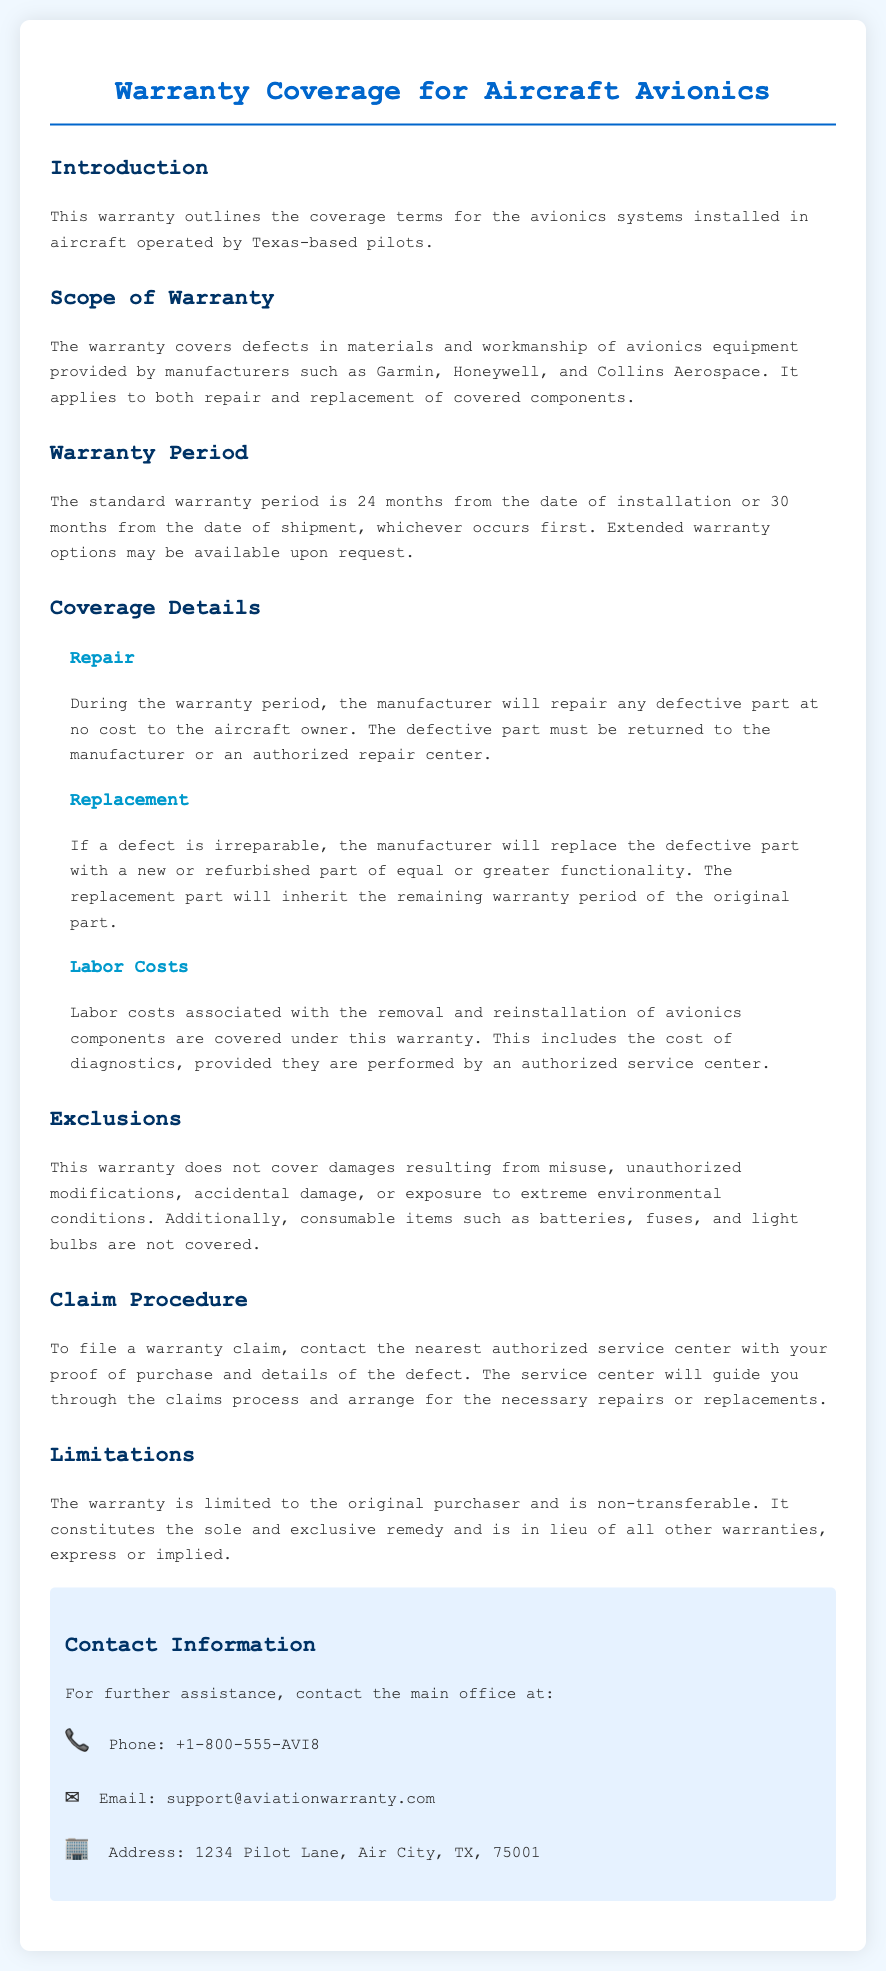What is the warranty period? The warranty period is 24 months from the date of installation or 30 months from the date of shipment, whichever occurs first.
Answer: 24 months Which companies are mentioned as manufacturers? The document lists manufacturers such as Garmin, Honeywell, and Collins Aerospace.
Answer: Garmin, Honeywell, Collins Aerospace What happens if a defect is irreparable? If a defect is irreparable, the manufacturer will replace the defective part with a new or refurbished part of equal or greater functionality.
Answer: Replace with new or refurbished part Are labor costs covered under the warranty? The document states that labor costs associated with the removal and reinstallation of avionics components are covered under this warranty.
Answer: Yes What is not covered under the warranty? The warranty does not cover damages resulting from misuse, unauthorized modifications, accidental damage, or exposure to extreme environmental conditions.
Answer: Misuse and unauthorized modifications How can a warranty claim be filed? To file a warranty claim, contact the nearest authorized service center with your proof of purchase and details of the defect.
Answer: Contact authorized service center Who is the warranty limited to? The warranty is limited to the original purchaser and is non-transferable.
Answer: Original purchaser What is the phone number for further assistance? The phone number provided for assistance is +1-800-555-AVI8.
Answer: +1-800-555-AVI8 